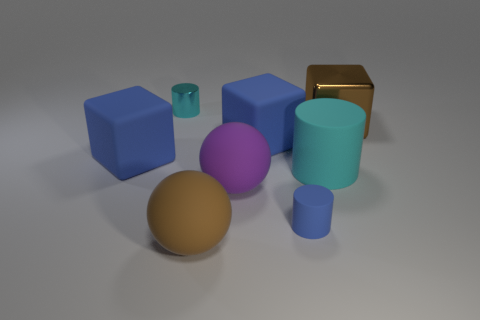Add 2 cyan matte objects. How many objects exist? 10 Subtract all cylinders. How many objects are left? 5 Add 6 big brown cubes. How many big brown cubes are left? 7 Add 7 big purple rubber blocks. How many big purple rubber blocks exist? 7 Subtract 1 purple spheres. How many objects are left? 7 Subtract all big cyan cylinders. Subtract all large cyan rubber objects. How many objects are left? 6 